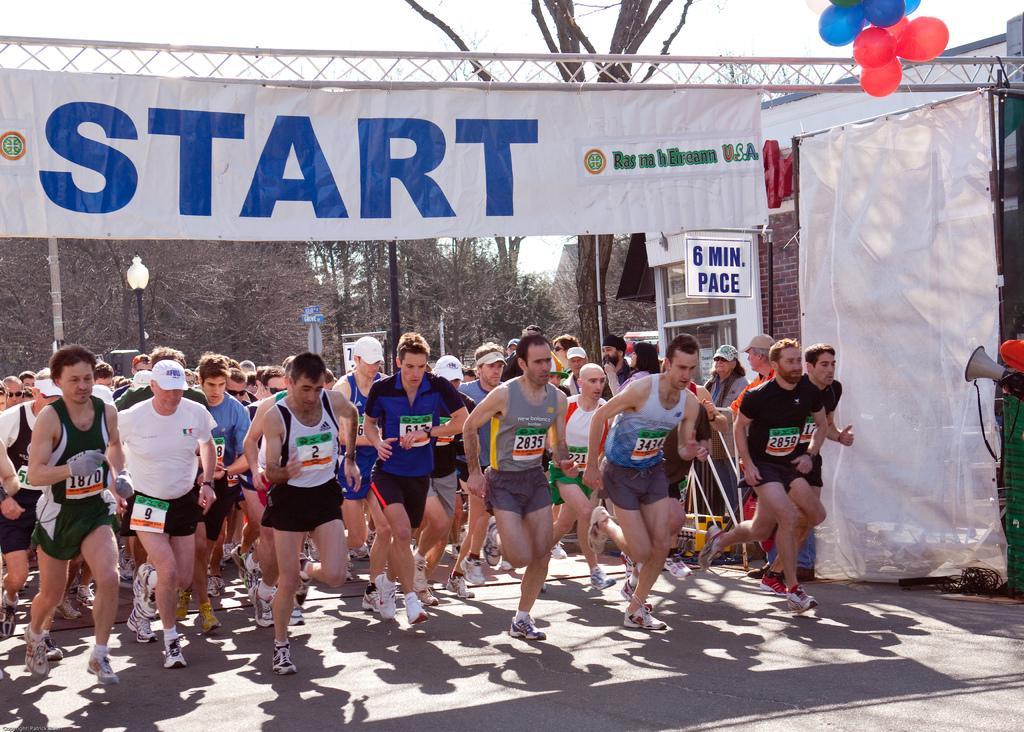Can you describe this image briefly? In this picture there are people, among them few people running on the road and we can see banners, truss, balloons, mega mike, board, house, poles and light. In the background of the image we can see trees and sky. 